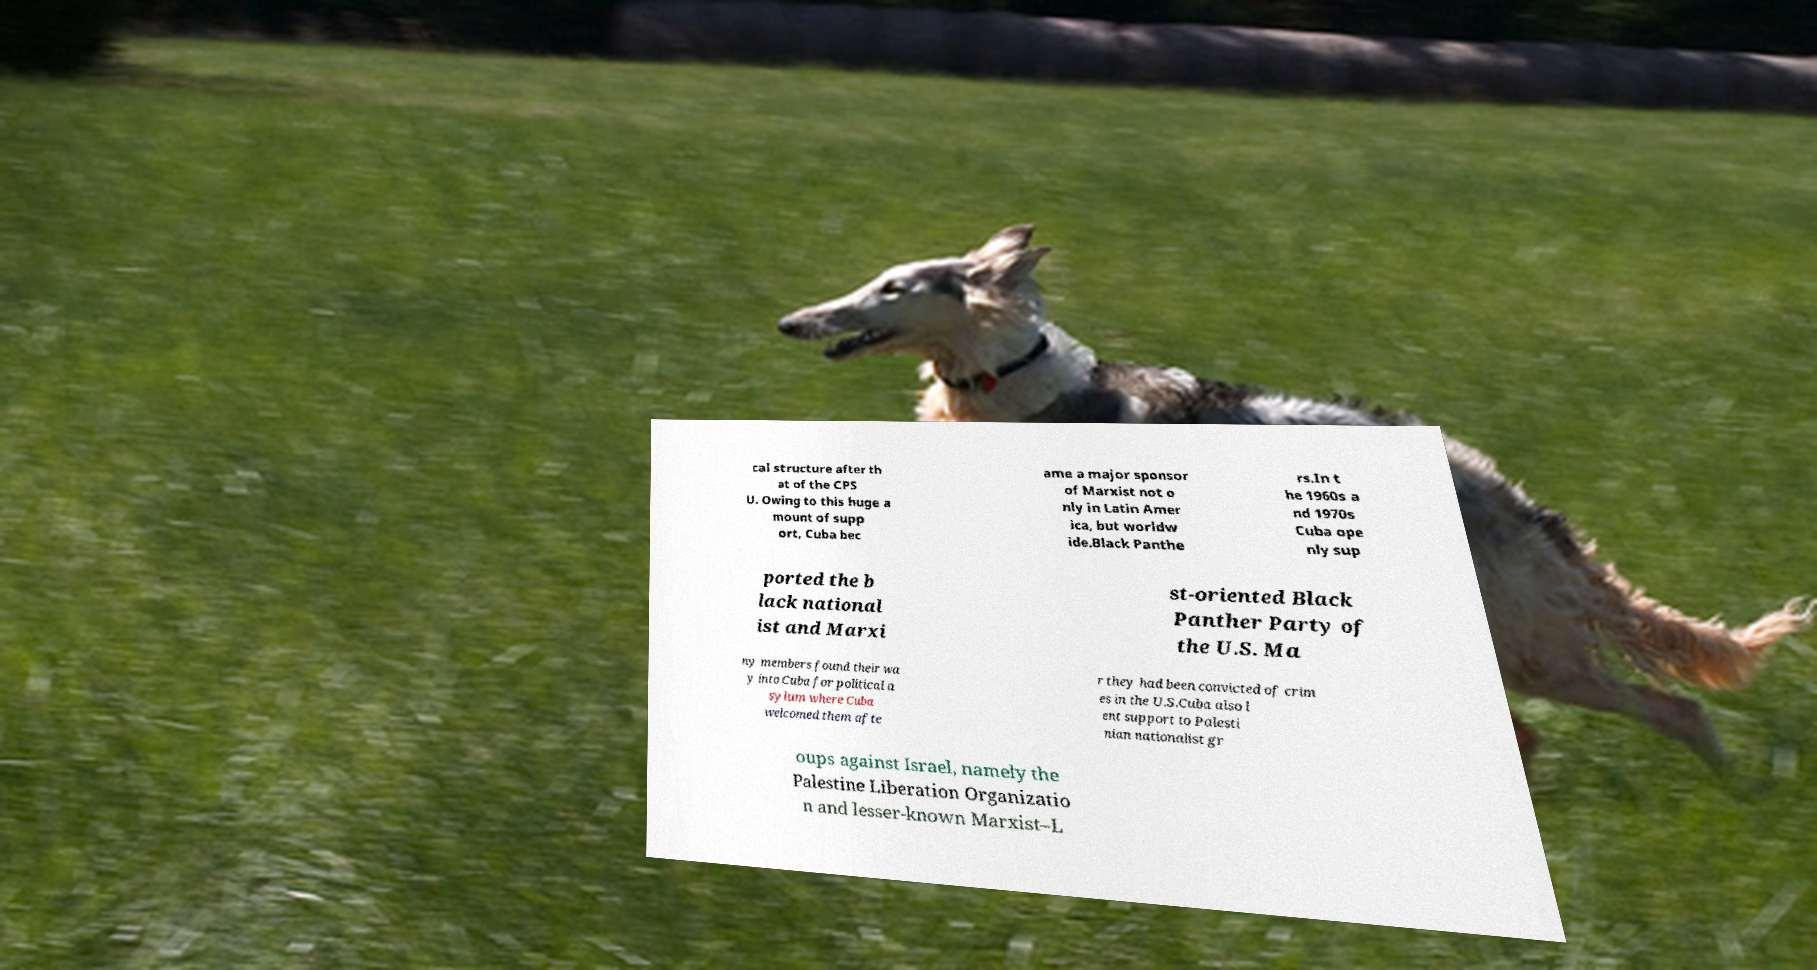Please identify and transcribe the text found in this image. cal structure after th at of the CPS U. Owing to this huge a mount of supp ort, Cuba bec ame a major sponsor of Marxist not o nly in Latin Amer ica, but worldw ide.Black Panthe rs.In t he 1960s a nd 1970s Cuba ope nly sup ported the b lack national ist and Marxi st-oriented Black Panther Party of the U.S. Ma ny members found their wa y into Cuba for political a sylum where Cuba welcomed them afte r they had been convicted of crim es in the U.S.Cuba also l ent support to Palesti nian nationalist gr oups against Israel, namely the Palestine Liberation Organizatio n and lesser-known Marxist–L 